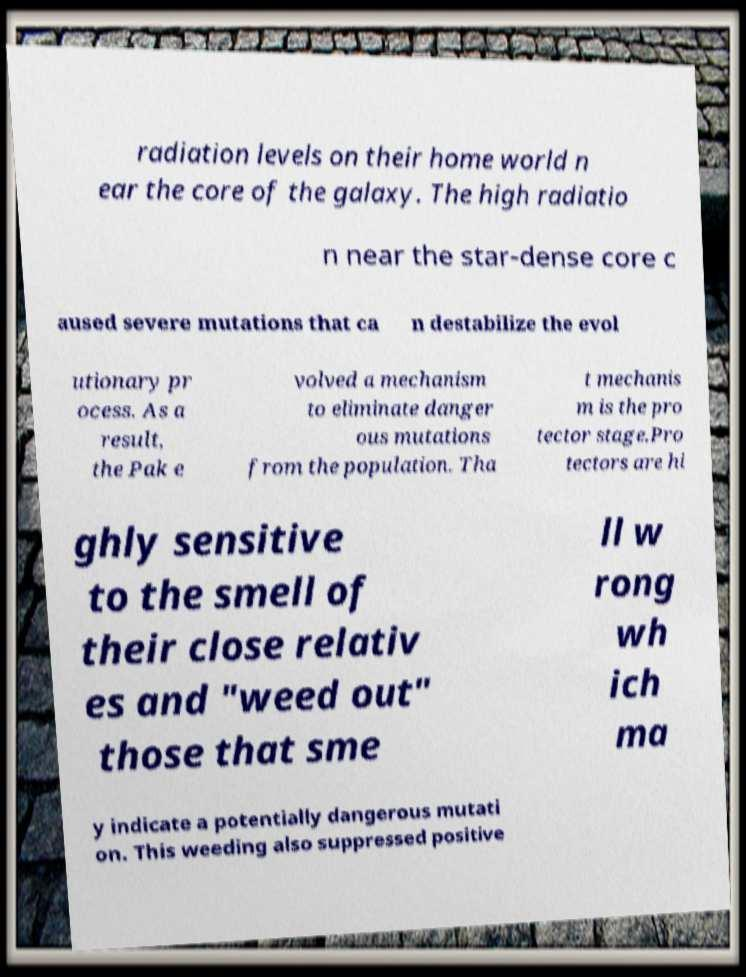Please read and relay the text visible in this image. What does it say? radiation levels on their home world n ear the core of the galaxy. The high radiatio n near the star-dense core c aused severe mutations that ca n destabilize the evol utionary pr ocess. As a result, the Pak e volved a mechanism to eliminate danger ous mutations from the population. Tha t mechanis m is the pro tector stage.Pro tectors are hi ghly sensitive to the smell of their close relativ es and "weed out" those that sme ll w rong wh ich ma y indicate a potentially dangerous mutati on. This weeding also suppressed positive 